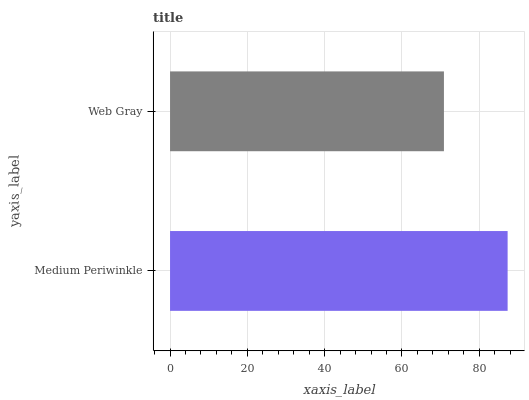Is Web Gray the minimum?
Answer yes or no. Yes. Is Medium Periwinkle the maximum?
Answer yes or no. Yes. Is Web Gray the maximum?
Answer yes or no. No. Is Medium Periwinkle greater than Web Gray?
Answer yes or no. Yes. Is Web Gray less than Medium Periwinkle?
Answer yes or no. Yes. Is Web Gray greater than Medium Periwinkle?
Answer yes or no. No. Is Medium Periwinkle less than Web Gray?
Answer yes or no. No. Is Medium Periwinkle the high median?
Answer yes or no. Yes. Is Web Gray the low median?
Answer yes or no. Yes. Is Web Gray the high median?
Answer yes or no. No. Is Medium Periwinkle the low median?
Answer yes or no. No. 